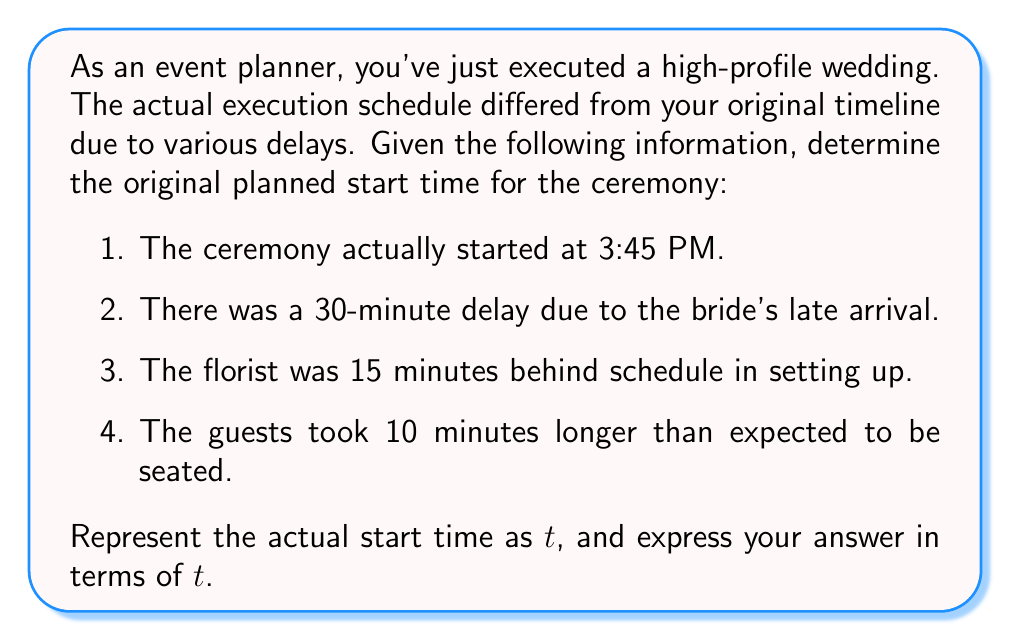Show me your answer to this math problem. Let's approach this step-by-step:

1. Define variables:
   Let $t$ = actual start time (3:45 PM)
   Let $x$ = original planned start time

2. Account for each delay:
   - Bride's late arrival: 30 minutes
   - Florist delay: 15 minutes
   - Guest seating delay: 10 minutes

3. Set up the equation:
   Actual start time = Planned start time + Total delays
   $$t = x + 30 + 15 + 10$$

4. Simplify:
   $$t = x + 55$$

5. Solve for $x$:
   $$x = t - 55$$

6. Express in terms of $t$:
   The original planned start time was 55 minutes before the actual start time, or $(t - 55)$ minutes.
Answer: $(t - 55)$ minutes 